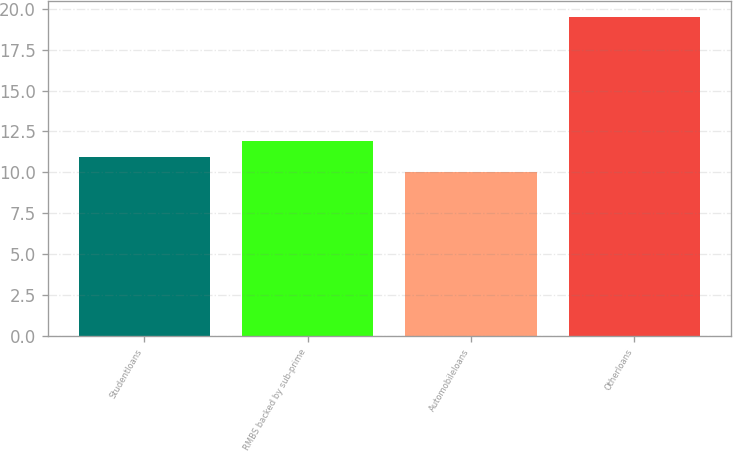<chart> <loc_0><loc_0><loc_500><loc_500><bar_chart><fcel>Studentloans<fcel>RMBS backed by sub-prime<fcel>Automobileloans<fcel>Otherloans<nl><fcel>10.95<fcel>11.9<fcel>10<fcel>19.5<nl></chart> 